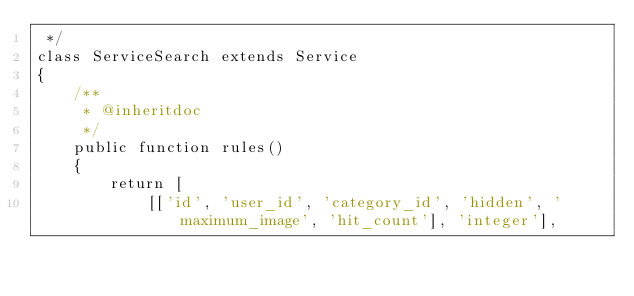<code> <loc_0><loc_0><loc_500><loc_500><_PHP_> */
class ServiceSearch extends Service
{
    /**
     * @inheritdoc
     */
    public function rules()
    {
        return [
            [['id', 'user_id', 'category_id', 'hidden', 'maximum_image', 'hit_count'], 'integer'],</code> 